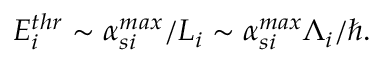Convert formula to latex. <formula><loc_0><loc_0><loc_500><loc_500>E _ { i } ^ { t h r } \sim \alpha _ { s i } ^ { \max } / L _ { i } \sim \alpha _ { s i } ^ { \max } \Lambda _ { i } / \hbar { . }</formula> 